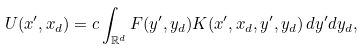<formula> <loc_0><loc_0><loc_500><loc_500>U ( x ^ { \prime } , x _ { d } ) = c \int _ { \mathbb { R } ^ { d } } F ( y ^ { \prime } , y _ { d } ) K ( x ^ { \prime } , x _ { d } , y ^ { \prime } , y _ { d } ) \, d y ^ { \prime } d y _ { d } ,</formula> 